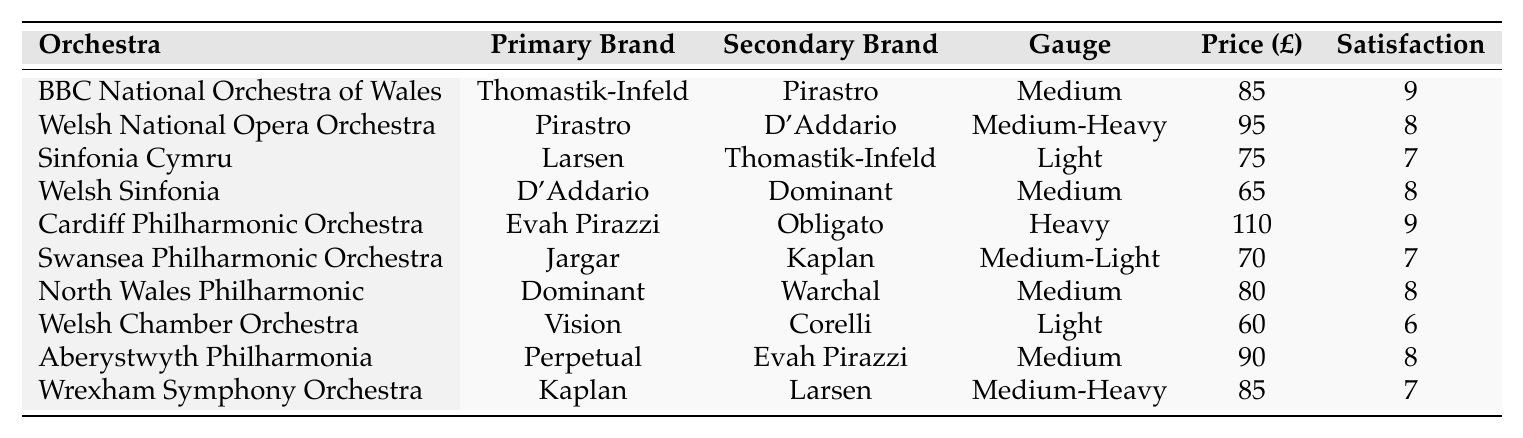What is the primary string brand used by the BBC National Orchestra of Wales? The table shows that the primary string brand for the BBC National Orchestra of Wales is Thomastik-Infeld.
Answer: Thomastik-Infeld Which orchestra has the highest player satisfaction rating? By examining the satisfaction ratings in the table, Cardiff Philharmonic Orchestra and BBC National Orchestra of Wales both have the highest rating of 9.
Answer: Cardiff Philharmonic Orchestra and BBC National Orchestra of Wales What is the average price per set of strings for the Welsh Sinfonia? The table indicates that the average price for the Welsh Sinfonia is £65, which is explicitly mentioned in the corresponding row.
Answer: £65 Are the primary string brands used by Welsh orchestras more likely to be either D'Addario or Pirastro? The table shows that D'Addario and Pirastro appear as primary brands 3 times out of 10, giving them a 30% probability, which is not more than half.
Answer: No What is the total average price for all the orchestras listed in the table? To calculate the total average price, sum the average prices: 85 + 95 + 75 + 65 + 110 + 70 + 80 + 60 + 90 + 85 =  1015. Then, divide by the number of orchestras (10): 1015/10 = £101.5.
Answer: £101.5 What gauge strings does the Aberystwyth Philharmonia prefer? The table indicates that the Aberystwyth Philharmonia prefers medium gauge strings, as stated in the corresponding row.
Answer: Medium Which orchestra uses Evah Pirazzi as their primary brand? From the table, it's clear that the Cardiff Philharmonic Orchestra uses Evah Pirazzi as their primary string brand.
Answer: Cardiff Philharmonic Orchestra What is the difference in player satisfaction between the Welsh Chamber Orchestra and the North Wales Philharmonic? The Welsh Chamber Orchestra has a satisfaction rating of 6, while the North Wales Philharmonic has 8. The difference is 8 - 6 = 2.
Answer: 2 Are all orchestras using medium gauge strings? The table shows that not all orchestras use medium gauge strings, as there are orchestras using light, heavy, and medium-heavy gauges as well.
Answer: No Which secondary string brand is most frequently used among these orchestras? By checking the secondary brand columns in the table, D'Addario and Pirastro each appear twice, while others appear less frequently, making D'Addario and Pirastro the most used.
Answer: D'Addario and Pirastro 